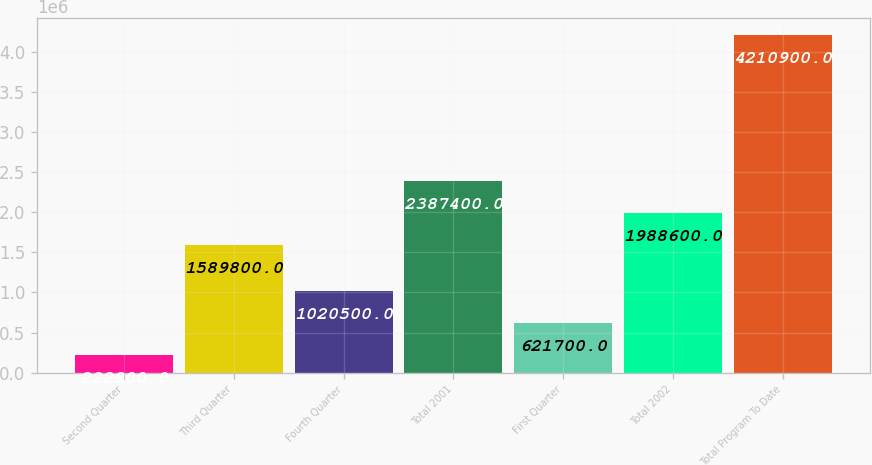Convert chart. <chart><loc_0><loc_0><loc_500><loc_500><bar_chart><fcel>Second Quarter<fcel>Third Quarter<fcel>Fourth Quarter<fcel>Total 2001<fcel>First Quarter<fcel>Total 2002<fcel>Total Program To Date<nl><fcel>222900<fcel>1.5898e+06<fcel>1.0205e+06<fcel>2.3874e+06<fcel>621700<fcel>1.9886e+06<fcel>4.2109e+06<nl></chart> 